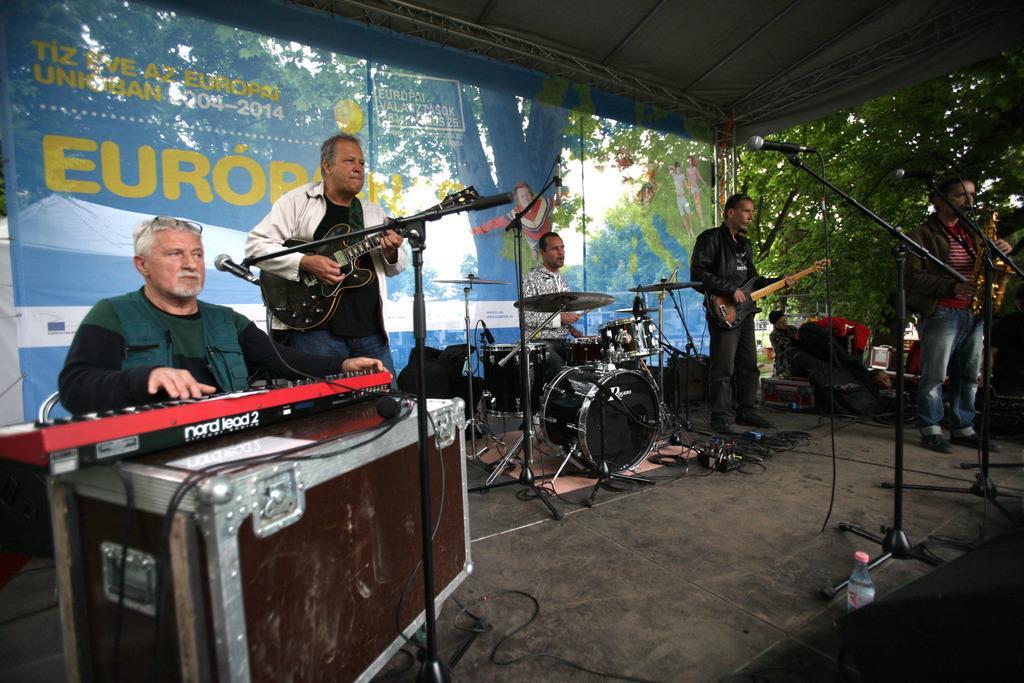Please provide a concise description of this image. In this picture there are musicians. The man to the left corner is playing keyboard. The man beside him is playing acoustic guitar. The man to the right corner is playing trumpet. The man beside him is playing a guitar. The man in the center is playing drums, On the floor there are boxes, drums, drum stands, cables, microphones and a bottle. In the background there is transparent banner. Through the banner a tent and tree can be seen. There is also another man in the background. 